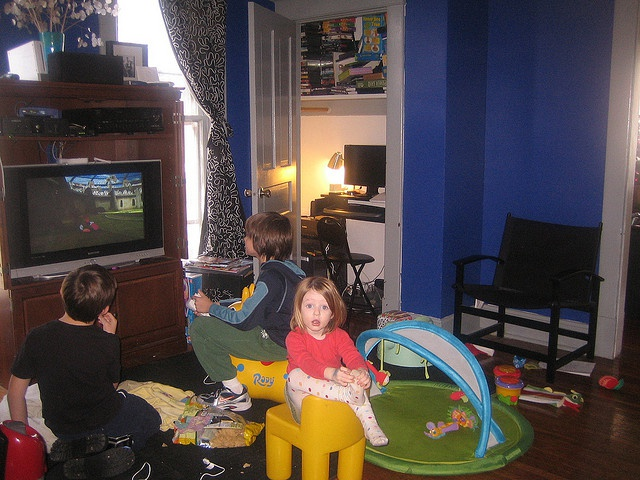Describe the objects in this image and their specific colors. I can see chair in black, gray, and navy tones, tv in black, gray, and darkgreen tones, people in black, brown, and maroon tones, people in black, gray, and maroon tones, and people in black, salmon, lightpink, lightgray, and brown tones in this image. 